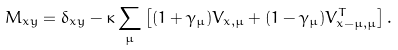Convert formula to latex. <formula><loc_0><loc_0><loc_500><loc_500>M _ { x y } = \delta _ { x y } - \kappa \sum _ { \mu } \left [ ( 1 + \gamma _ { \mu } ) V _ { x , \mu } + ( 1 - \gamma _ { \mu } ) V ^ { T } _ { x - \mu , \mu } \right ] .</formula> 